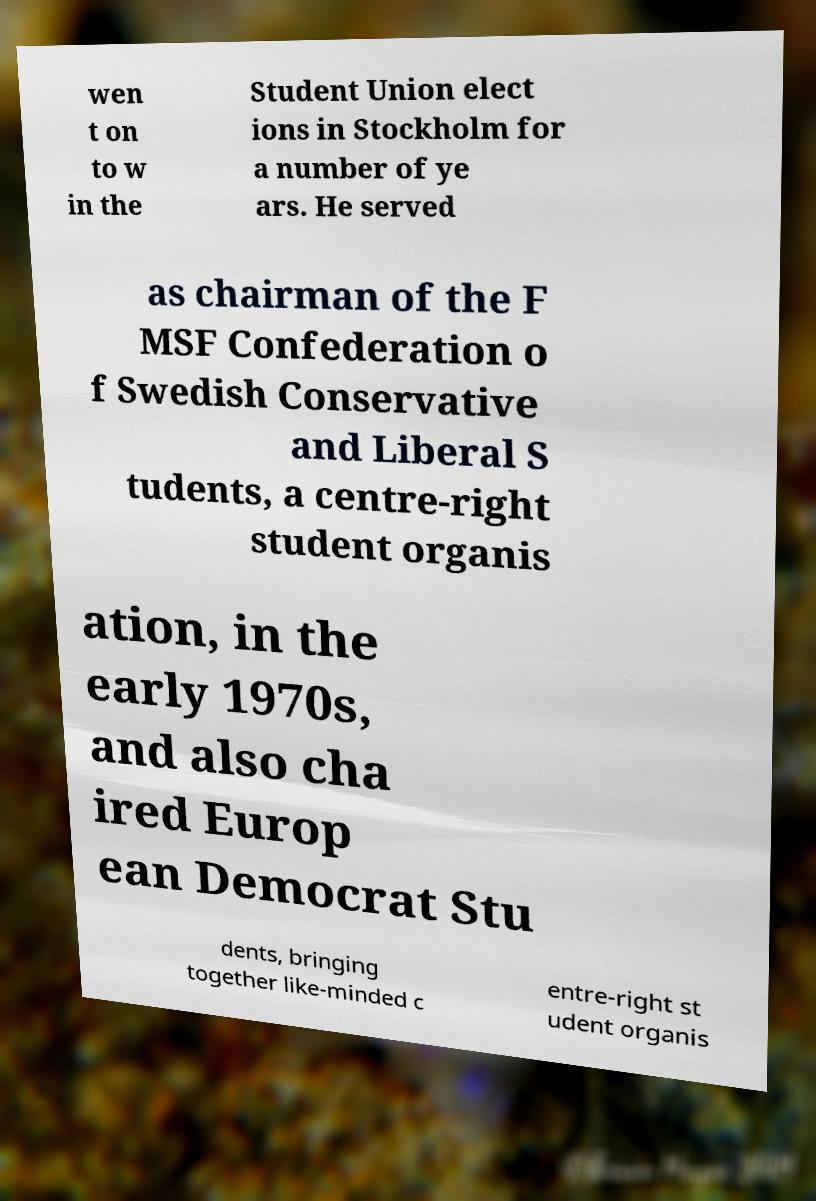Could you assist in decoding the text presented in this image and type it out clearly? wen t on to w in the Student Union elect ions in Stockholm for a number of ye ars. He served as chairman of the F MSF Confederation o f Swedish Conservative and Liberal S tudents, a centre-right student organis ation, in the early 1970s, and also cha ired Europ ean Democrat Stu dents, bringing together like-minded c entre-right st udent organis 